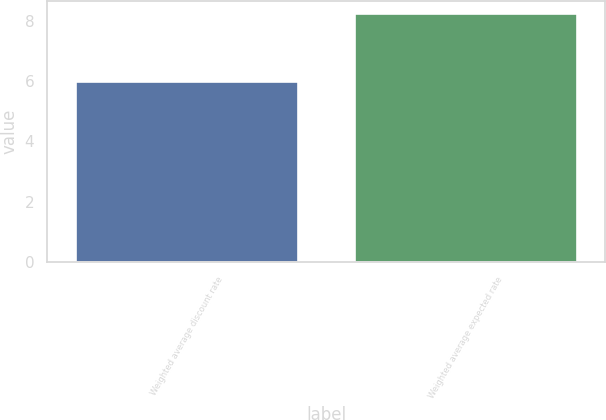<chart> <loc_0><loc_0><loc_500><loc_500><bar_chart><fcel>Weighted average discount rate<fcel>Weighted average expected rate<nl><fcel>6<fcel>8.25<nl></chart> 